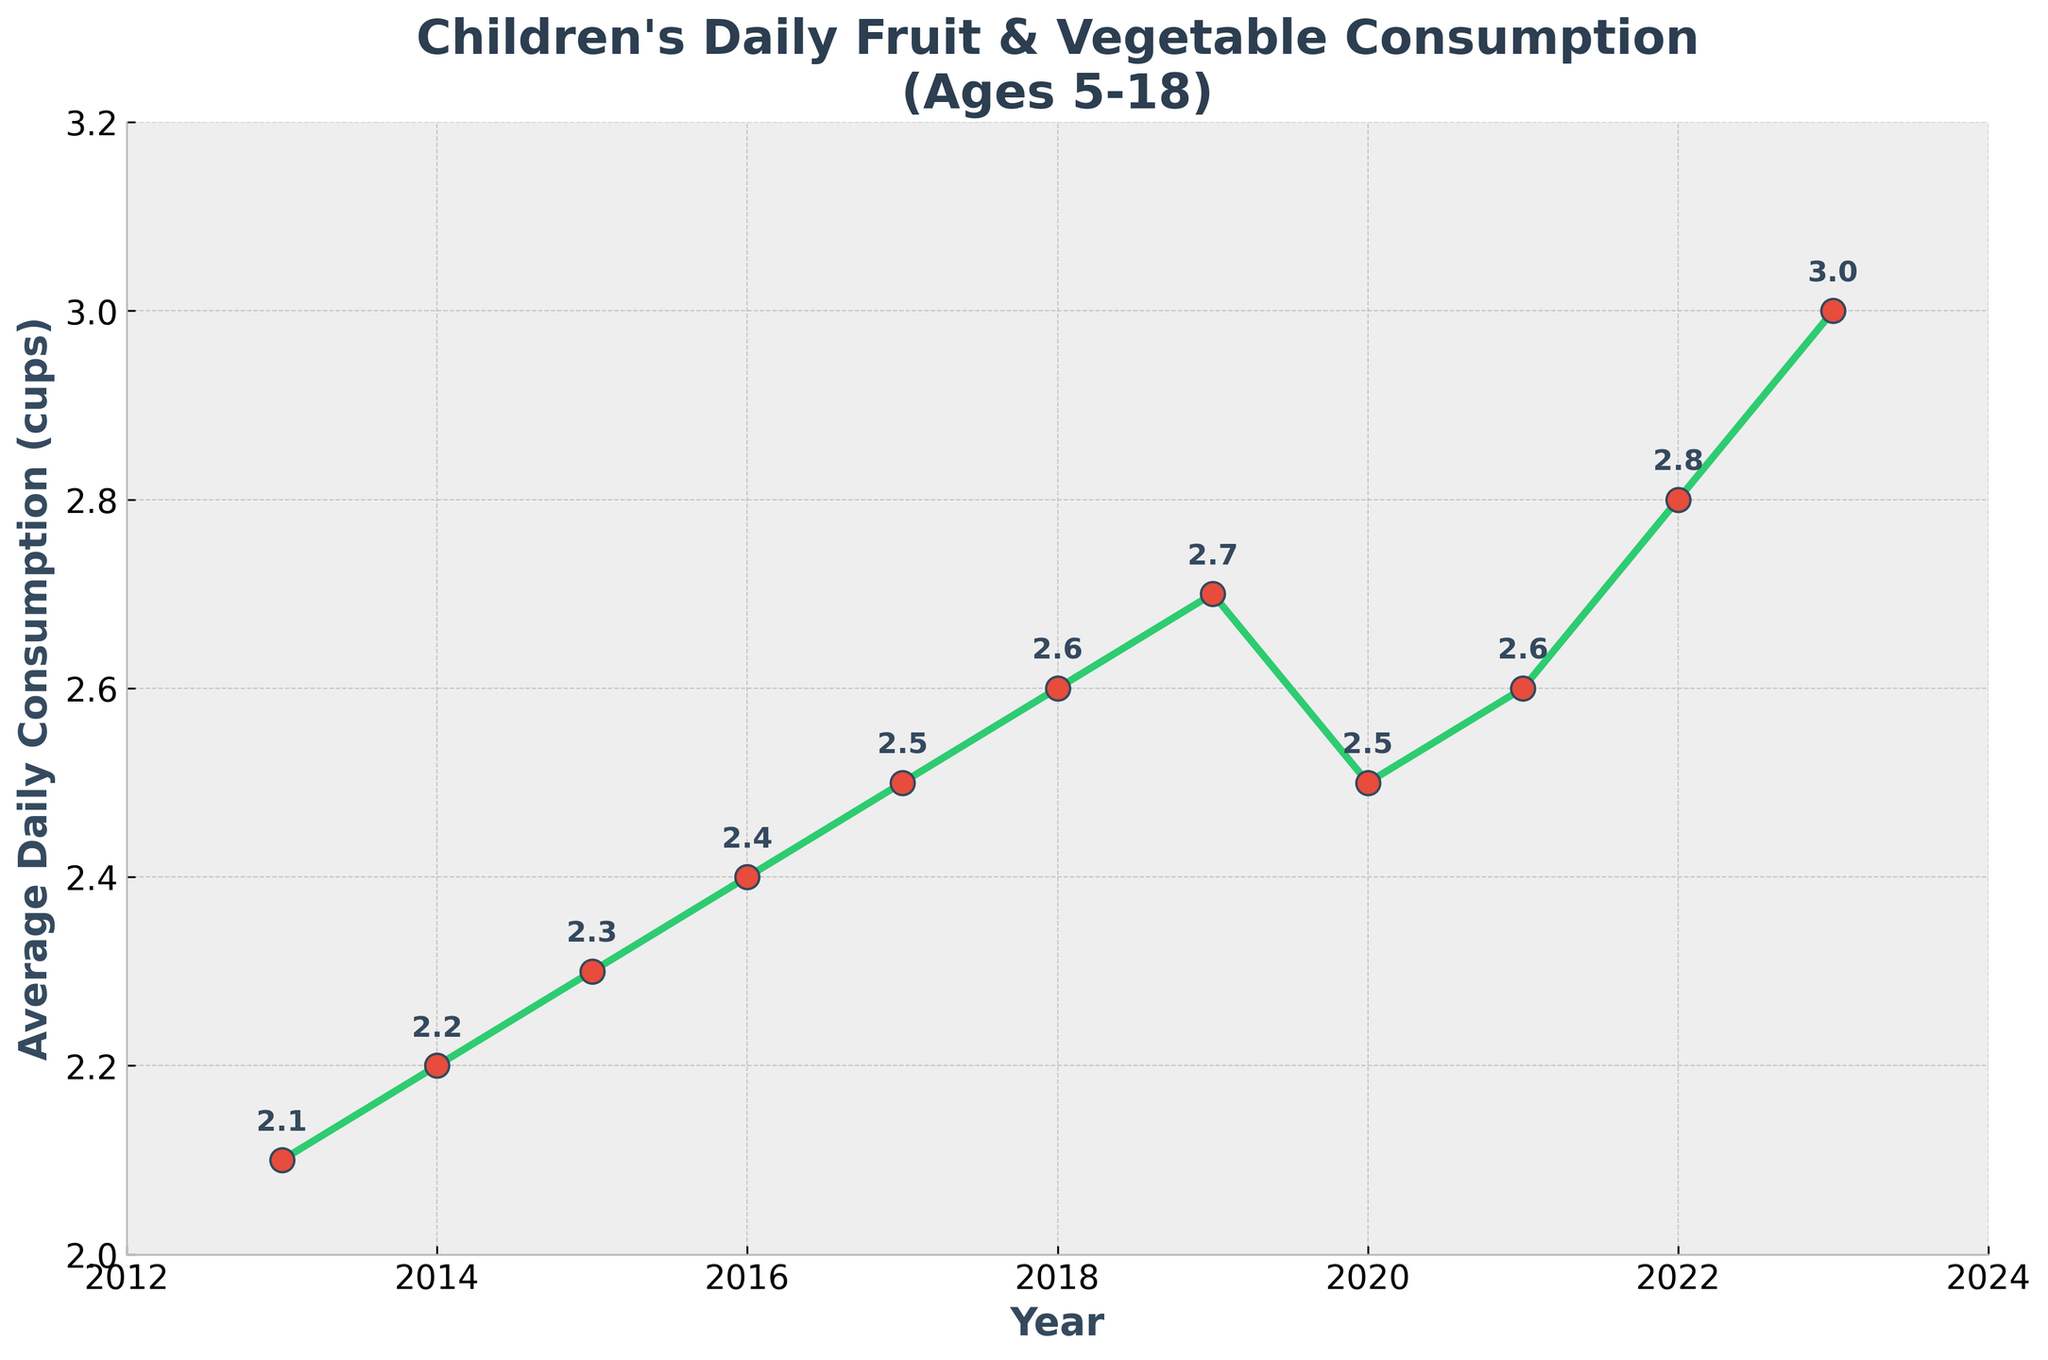What trend do you observe in the average daily fruit and vegetable consumption among children from 2013 to 2023? The trend shows a gradual increase in the average daily fruit and vegetable consumption, rising from 2.1 cups in 2013 to 3.0 cups in 2023, with a slight dip in 2020.
Answer: Gradual increase In which year did the average daily fruit and vegetable consumption see the highest value? The highest value is observed at 3.0 cups, which corresponds to the year 2023.
Answer: 2023 What is the difference in the average daily fruit and vegetable consumption between 2013 and 2023? Subtract the 2013 value (2.1 cups) from the 2023 value (3.0 cups) to get the difference: 3.0 - 2.1 = 0.9 cups.
Answer: 0.9 cups Which year(s) show a decline in the average daily fruit and vegetable consumption compared to the previous year? The average daily consumption declined from 2.7 cups in 2019 to 2.5 cups in 2020.
Answer: 2020 What is the overall increase in average daily fruit and vegetable consumption from 2013 to 2019? Subtract the 2013 value (2.1 cups) from the 2019 value (2.7 cups) to get the overall increase: 2.7 - 2.1 = 0.6 cups.
Answer: 0.6 cups How many times did the consumption remain the same in consecutive years? The consumption remained the same between 2017-2018 (2.5 cups) and 2020-2021 (2.6 cups) for a total of two times.
Answer: 2 times Which years had an average daily fruit and vegetable consumption of 2.6 cups? The years with an average daily consumption of 2.6 cups are 2018 and 2021.
Answer: 2018 and 2021 What is the average consumption over the decade? Sum all the values (2.1 + 2.2 + 2.3 + 2.4 + 2.5 + 2.6 + 2.7 + 2.5 + 2.6 + 2.8 + 3.0 = 28.7 cups) and divide by the number of years (11) to get the average: 28.7 / 11 ≈ 2.61 cups.
Answer: 2.61 cups Compare the consumption in 2017 and 2022. In which year was it higher and by how much? The consumption in 2017 was 2.5 cups, and in 2022 it was 2.8 cups. The difference is 2.8 - 2.5 = 0.3 cups, with 2022 being higher.
Answer: 2022, by 0.3 cups What visual cue indicates the year with the highest average daily fruit and vegetable consumption? The highest point on the line, marked with a red marker, indicates the year with the highest consumption, which is 2023 at 3.0 cups.
Answer: Highest point on the line (2023) 